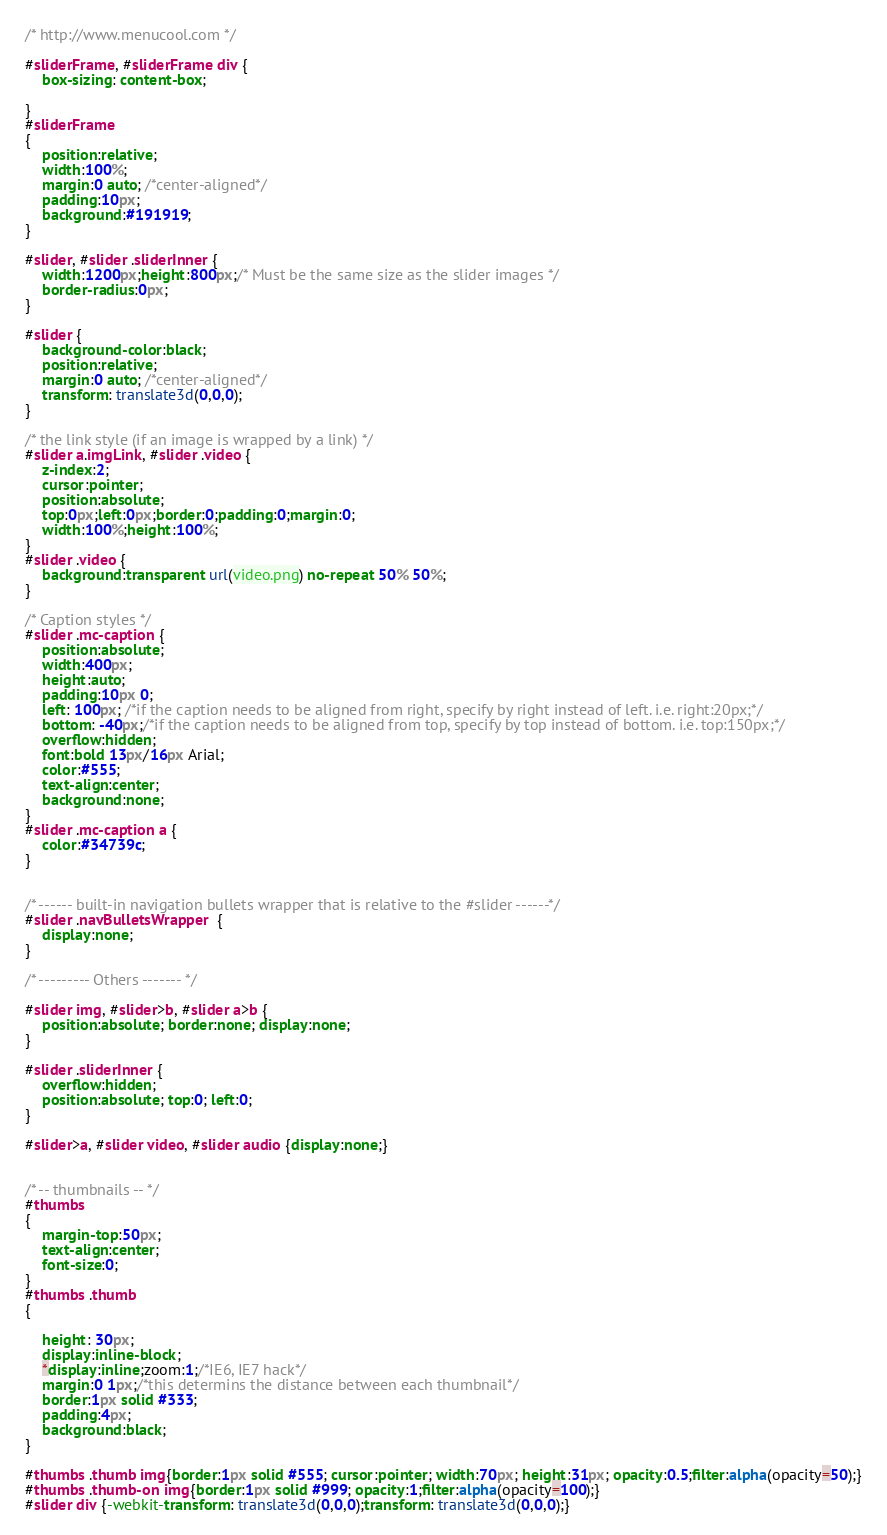Convert code to text. <code><loc_0><loc_0><loc_500><loc_500><_CSS_>/* http://www.menucool.com */

#sliderFrame, #sliderFrame div {
    box-sizing: content-box;

}
#sliderFrame 
{
    position:relative;
    width:100%;
    margin:0 auto; /*center-aligned*/
    padding:10px;
    background:#191919;
} 

#slider, #slider .sliderInner {
    width:1200px;height:800px;/* Must be the same size as the slider images */
    border-radius:0px;
}

#slider {
    background-color:black;
    position:relative;
    margin:0 auto; /*center-aligned*/
    transform: translate3d(0,0,0);
}

/* the link style (if an image is wrapped by a link) */
#slider a.imgLink, #slider .video {
    z-index:2;
    cursor:pointer;
    position:absolute;
    top:0px;left:0px;border:0;padding:0;margin:0;
    width:100%;height:100%;
}
#slider .video {
    background:transparent url(video.png) no-repeat 50% 50%;
}

/* Caption styles */
#slider .mc-caption {
    position:absolute;
    width:400px;
    height:auto;
    padding:10px 0;
    left: 100px; /*if the caption needs to be aligned from right, specify by right instead of left. i.e. right:20px;*/
    bottom: -40px;/*if the caption needs to be aligned from top, specify by top instead of bottom. i.e. top:150px;*/
    overflow:hidden;
    font:bold 13px/16px Arial;
    color:#555;
    text-align:center;
    background:none;
}
#slider .mc-caption a { 
    color:#34739c;
}


/* ------ built-in navigation bullets wrapper that is relative to the #slider ------*/
#slider .navBulletsWrapper  {
    display:none;
}

/* --------- Others ------- */

#slider img, #slider>b, #slider a>b {
    position:absolute; border:none; display:none;
}

#slider .sliderInner {
    overflow:hidden;
    position:absolute; top:0; left:0;
}

#slider>a, #slider video, #slider audio {display:none;}


/* -- thumbnails -- */
#thumbs 
{
    margin-top:50px;
    text-align:center;
    font-size:0;
}
#thumbs .thumb 
{

    height: 30px;
    display:inline-block;
    *display:inline;zoom:1;/*IE6, IE7 hack*/
    margin:0 1px;/*this determins the distance between each thumbnail*/
    border:1px solid #333;
    padding:4px;
    background:black;
}

#thumbs .thumb img{border:1px solid #555; cursor:pointer; width:70px; height:31px; opacity:0.5;filter:alpha(opacity=50);}
#thumbs .thumb-on img{border:1px solid #999; opacity:1;filter:alpha(opacity=100);}
#slider div {-webkit-transform: translate3d(0,0,0);transform: translate3d(0,0,0);}
</code> 